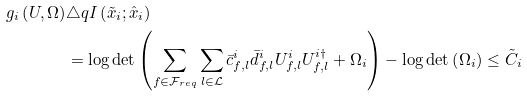<formula> <loc_0><loc_0><loc_500><loc_500>g _ { i } \left ( U , \Omega \right ) & \triangle q I \left ( \tilde { x } _ { i } ; \hat { x } _ { i } \right ) \\ & = \log \det \left ( \sum _ { f \in \mathcal { F } _ { r e q } } \sum _ { l \in \mathcal { L } } \bar { c } _ { f , l } ^ { i } \bar { d } _ { f , l } ^ { i } U _ { f , l } ^ { i } U _ { f , l } ^ { i \dagger } + \Omega _ { i } \right ) - \log \det \left ( \Omega _ { i } \right ) \leq \tilde { C } _ { i }</formula> 